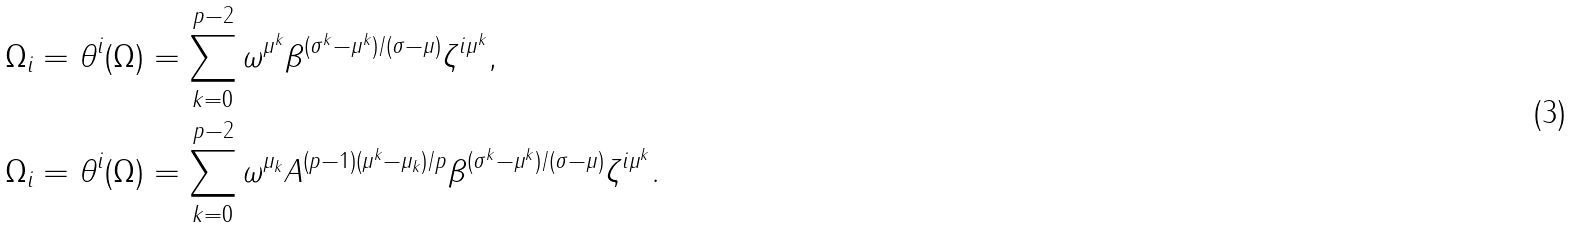<formula> <loc_0><loc_0><loc_500><loc_500>& \Omega _ { i } = \theta ^ { i } ( \Omega ) = \sum _ { k = 0 } ^ { p - 2 } \omega ^ { \mu ^ { k } } \beta ^ { ( \sigma ^ { k } - \mu ^ { k } ) / ( \sigma - \mu ) } \zeta ^ { i \mu ^ { k } } , \\ & \Omega _ { i } = \theta ^ { i } ( \Omega ) = \sum _ { k = 0 } ^ { p - 2 } \omega ^ { \mu _ { k } } A ^ { ( p - 1 ) ( \mu ^ { k } - \mu _ { k } ) / p } \beta ^ { ( \sigma ^ { k } - \mu ^ { k } ) / ( \sigma - \mu ) } \zeta ^ { i \mu ^ { k } } . \\</formula> 